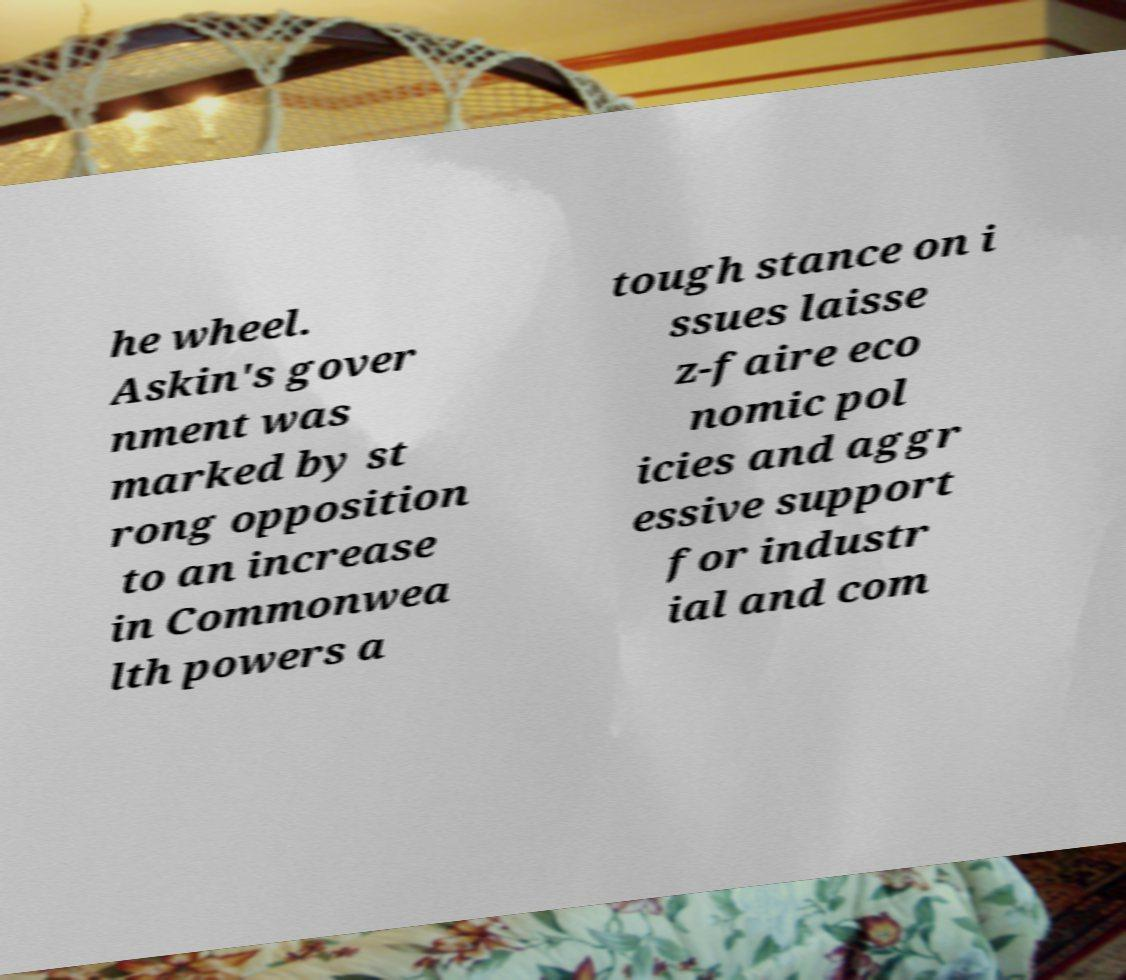Could you assist in decoding the text presented in this image and type it out clearly? he wheel. Askin's gover nment was marked by st rong opposition to an increase in Commonwea lth powers a tough stance on i ssues laisse z-faire eco nomic pol icies and aggr essive support for industr ial and com 